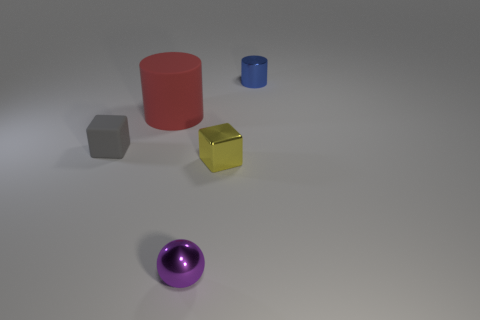Add 3 small yellow shiny cubes. How many objects exist? 8 Subtract 1 blocks. How many blocks are left? 1 Subtract all big matte cylinders. Subtract all tiny things. How many objects are left? 0 Add 5 metallic cylinders. How many metallic cylinders are left? 6 Add 1 metal cylinders. How many metal cylinders exist? 2 Subtract 0 blue spheres. How many objects are left? 5 Subtract all cylinders. How many objects are left? 3 Subtract all brown cubes. Subtract all gray cylinders. How many cubes are left? 2 Subtract all gray balls. How many gray cylinders are left? 0 